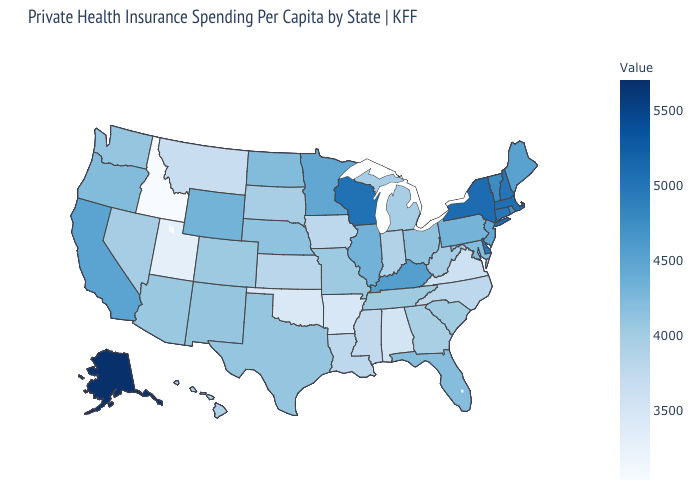Does Indiana have a lower value than Minnesota?
Give a very brief answer. Yes. Among the states that border Tennessee , does Arkansas have the lowest value?
Give a very brief answer. Yes. Does Idaho have the lowest value in the USA?
Answer briefly. Yes. Is the legend a continuous bar?
Concise answer only. Yes. 